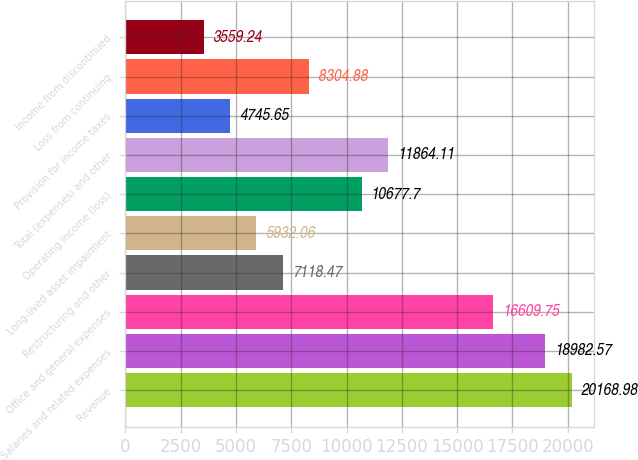Convert chart to OTSL. <chart><loc_0><loc_0><loc_500><loc_500><bar_chart><fcel>Revenue<fcel>Salaries and related expenses<fcel>Office and general expenses<fcel>Restructuring and other<fcel>Long-lived asset impairment<fcel>Operating income (loss)<fcel>Total (expenses) and other<fcel>Provision for income taxes<fcel>Loss from continuing<fcel>Income from discontinued<nl><fcel>20169<fcel>18982.6<fcel>16609.8<fcel>7118.47<fcel>5932.06<fcel>10677.7<fcel>11864.1<fcel>4745.65<fcel>8304.88<fcel>3559.24<nl></chart> 